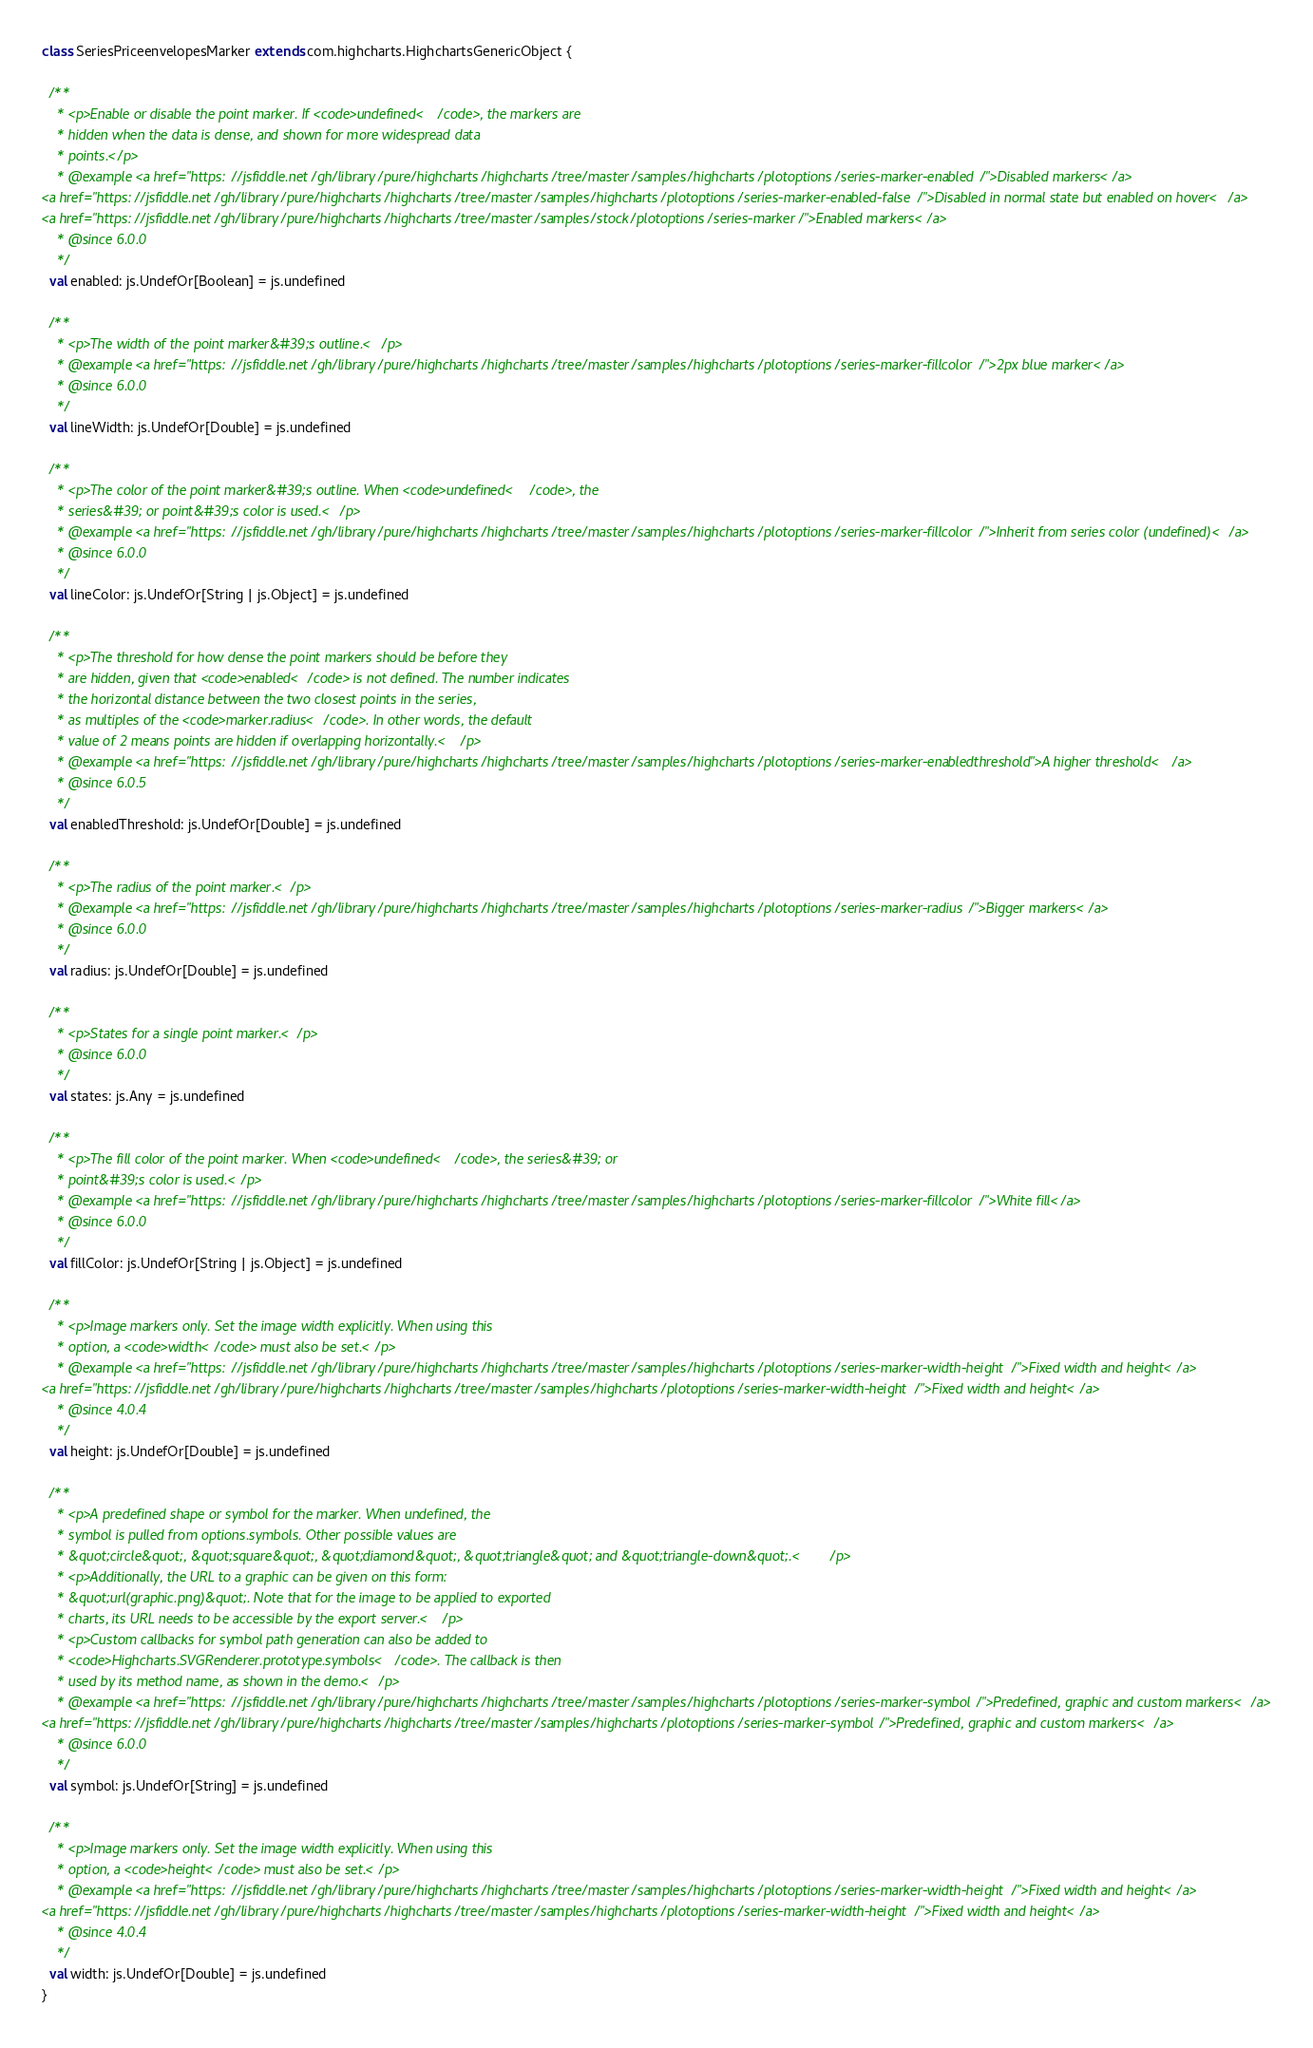Convert code to text. <code><loc_0><loc_0><loc_500><loc_500><_Scala_>class SeriesPriceenvelopesMarker extends com.highcharts.HighchartsGenericObject {

  /**
    * <p>Enable or disable the point marker. If <code>undefined</code>, the markers are
    * hidden when the data is dense, and shown for more widespread data
    * points.</p>
    * @example <a href="https://jsfiddle.net/gh/library/pure/highcharts/highcharts/tree/master/samples/highcharts/plotoptions/series-marker-enabled/">Disabled markers</a>
<a href="https://jsfiddle.net/gh/library/pure/highcharts/highcharts/tree/master/samples/highcharts/plotoptions/series-marker-enabled-false/">Disabled in normal state but enabled on hover</a>
<a href="https://jsfiddle.net/gh/library/pure/highcharts/highcharts/tree/master/samples/stock/plotoptions/series-marker/">Enabled markers</a>
    * @since 6.0.0
    */
  val enabled: js.UndefOr[Boolean] = js.undefined

  /**
    * <p>The width of the point marker&#39;s outline.</p>
    * @example <a href="https://jsfiddle.net/gh/library/pure/highcharts/highcharts/tree/master/samples/highcharts/plotoptions/series-marker-fillcolor/">2px blue marker</a>
    * @since 6.0.0
    */
  val lineWidth: js.UndefOr[Double] = js.undefined

  /**
    * <p>The color of the point marker&#39;s outline. When <code>undefined</code>, the
    * series&#39; or point&#39;s color is used.</p>
    * @example <a href="https://jsfiddle.net/gh/library/pure/highcharts/highcharts/tree/master/samples/highcharts/plotoptions/series-marker-fillcolor/">Inherit from series color (undefined)</a>
    * @since 6.0.0
    */
  val lineColor: js.UndefOr[String | js.Object] = js.undefined

  /**
    * <p>The threshold for how dense the point markers should be before they
    * are hidden, given that <code>enabled</code> is not defined. The number indicates
    * the horizontal distance between the two closest points in the series,
    * as multiples of the <code>marker.radius</code>. In other words, the default
    * value of 2 means points are hidden if overlapping horizontally.</p>
    * @example <a href="https://jsfiddle.net/gh/library/pure/highcharts/highcharts/tree/master/samples/highcharts/plotoptions/series-marker-enabledthreshold">A higher threshold</a>
    * @since 6.0.5
    */
  val enabledThreshold: js.UndefOr[Double] = js.undefined

  /**
    * <p>The radius of the point marker.</p>
    * @example <a href="https://jsfiddle.net/gh/library/pure/highcharts/highcharts/tree/master/samples/highcharts/plotoptions/series-marker-radius/">Bigger markers</a>
    * @since 6.0.0
    */
  val radius: js.UndefOr[Double] = js.undefined

  /**
    * <p>States for a single point marker.</p>
    * @since 6.0.0
    */
  val states: js.Any = js.undefined

  /**
    * <p>The fill color of the point marker. When <code>undefined</code>, the series&#39; or
    * point&#39;s color is used.</p>
    * @example <a href="https://jsfiddle.net/gh/library/pure/highcharts/highcharts/tree/master/samples/highcharts/plotoptions/series-marker-fillcolor/">White fill</a>
    * @since 6.0.0
    */
  val fillColor: js.UndefOr[String | js.Object] = js.undefined

  /**
    * <p>Image markers only. Set the image width explicitly. When using this
    * option, a <code>width</code> must also be set.</p>
    * @example <a href="https://jsfiddle.net/gh/library/pure/highcharts/highcharts/tree/master/samples/highcharts/plotoptions/series-marker-width-height/">Fixed width and height</a>
<a href="https://jsfiddle.net/gh/library/pure/highcharts/highcharts/tree/master/samples/highcharts/plotoptions/series-marker-width-height/">Fixed width and height</a>
    * @since 4.0.4
    */
  val height: js.UndefOr[Double] = js.undefined

  /**
    * <p>A predefined shape or symbol for the marker. When undefined, the
    * symbol is pulled from options.symbols. Other possible values are
    * &quot;circle&quot;, &quot;square&quot;, &quot;diamond&quot;, &quot;triangle&quot; and &quot;triangle-down&quot;.</p>
    * <p>Additionally, the URL to a graphic can be given on this form:
    * &quot;url(graphic.png)&quot;. Note that for the image to be applied to exported
    * charts, its URL needs to be accessible by the export server.</p>
    * <p>Custom callbacks for symbol path generation can also be added to
    * <code>Highcharts.SVGRenderer.prototype.symbols</code>. The callback is then
    * used by its method name, as shown in the demo.</p>
    * @example <a href="https://jsfiddle.net/gh/library/pure/highcharts/highcharts/tree/master/samples/highcharts/plotoptions/series-marker-symbol/">Predefined, graphic and custom markers</a>
<a href="https://jsfiddle.net/gh/library/pure/highcharts/highcharts/tree/master/samples/highcharts/plotoptions/series-marker-symbol/">Predefined, graphic and custom markers</a>
    * @since 6.0.0
    */
  val symbol: js.UndefOr[String] = js.undefined

  /**
    * <p>Image markers only. Set the image width explicitly. When using this
    * option, a <code>height</code> must also be set.</p>
    * @example <a href="https://jsfiddle.net/gh/library/pure/highcharts/highcharts/tree/master/samples/highcharts/plotoptions/series-marker-width-height/">Fixed width and height</a>
<a href="https://jsfiddle.net/gh/library/pure/highcharts/highcharts/tree/master/samples/highcharts/plotoptions/series-marker-width-height/">Fixed width and height</a>
    * @since 4.0.4
    */
  val width: js.UndefOr[Double] = js.undefined
}
</code> 